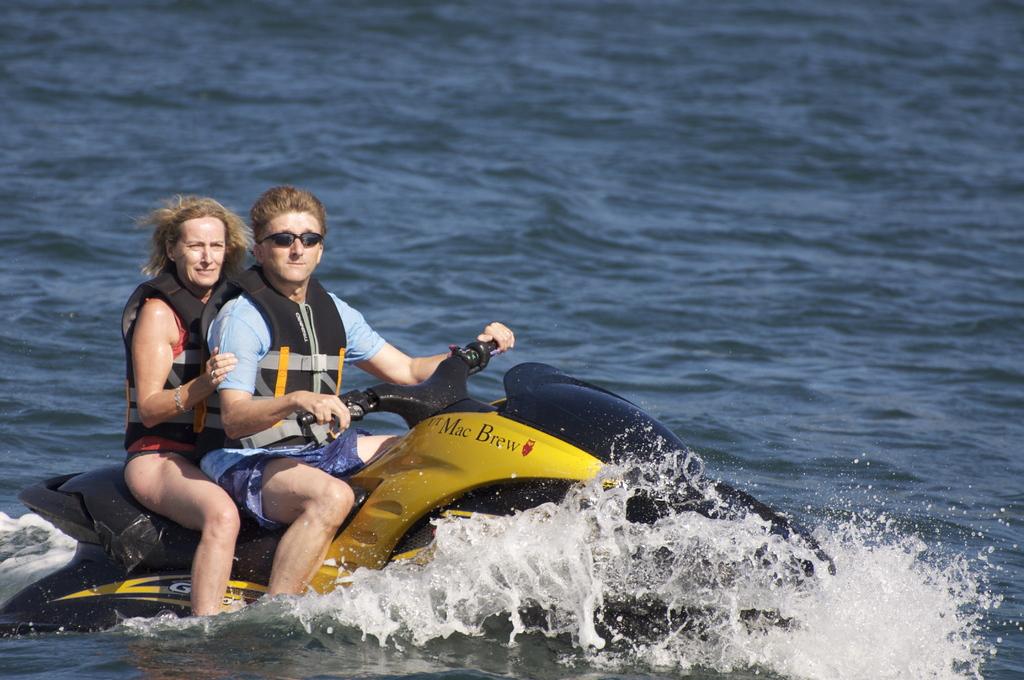What does the jet ski say?
Make the answer very short. Mac brew. 